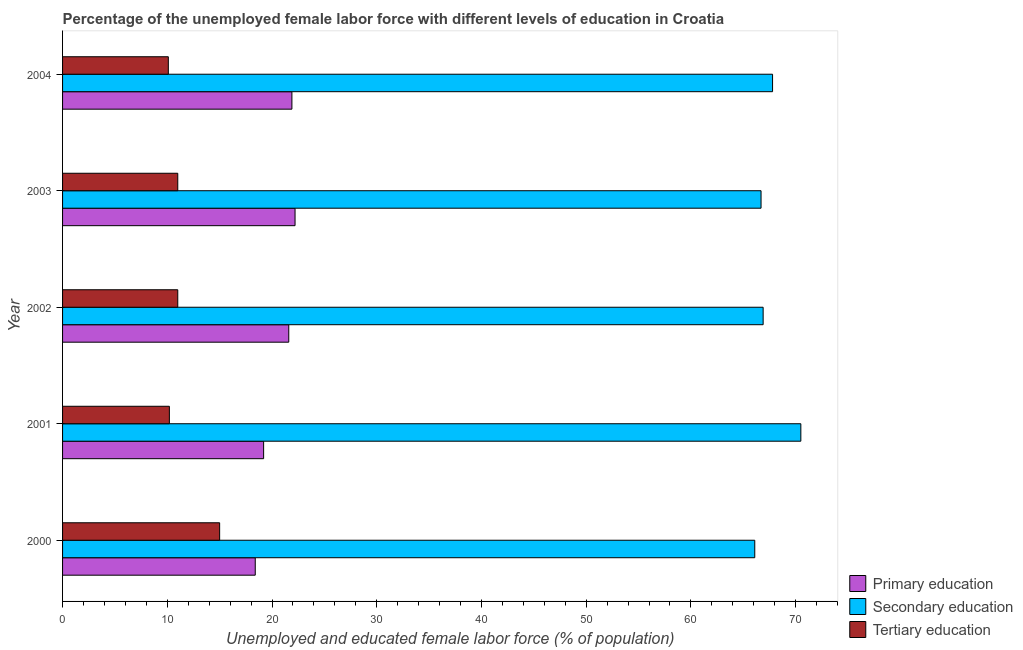Are the number of bars per tick equal to the number of legend labels?
Offer a terse response. Yes. How many bars are there on the 4th tick from the top?
Offer a very short reply. 3. How many bars are there on the 1st tick from the bottom?
Ensure brevity in your answer.  3. What is the percentage of female labor force who received primary education in 2001?
Offer a very short reply. 19.2. Across all years, what is the maximum percentage of female labor force who received secondary education?
Provide a short and direct response. 70.5. Across all years, what is the minimum percentage of female labor force who received secondary education?
Offer a terse response. 66.1. In which year was the percentage of female labor force who received tertiary education minimum?
Offer a terse response. 2004. What is the total percentage of female labor force who received tertiary education in the graph?
Your response must be concise. 57.3. What is the difference between the percentage of female labor force who received primary education in 2003 and that in 2004?
Give a very brief answer. 0.3. What is the difference between the percentage of female labor force who received secondary education in 2003 and the percentage of female labor force who received primary education in 2000?
Make the answer very short. 48.3. What is the average percentage of female labor force who received secondary education per year?
Give a very brief answer. 67.6. In the year 2004, what is the difference between the percentage of female labor force who received tertiary education and percentage of female labor force who received primary education?
Your response must be concise. -11.8. What is the ratio of the percentage of female labor force who received secondary education in 2001 to that in 2003?
Your response must be concise. 1.06. Is the percentage of female labor force who received tertiary education in 2001 less than that in 2002?
Offer a very short reply. Yes. In how many years, is the percentage of female labor force who received secondary education greater than the average percentage of female labor force who received secondary education taken over all years?
Your answer should be compact. 2. Is the sum of the percentage of female labor force who received primary education in 2000 and 2003 greater than the maximum percentage of female labor force who received tertiary education across all years?
Your answer should be compact. Yes. What does the 1st bar from the bottom in 2003 represents?
Offer a very short reply. Primary education. Is it the case that in every year, the sum of the percentage of female labor force who received primary education and percentage of female labor force who received secondary education is greater than the percentage of female labor force who received tertiary education?
Give a very brief answer. Yes. How many years are there in the graph?
Keep it short and to the point. 5. What is the difference between two consecutive major ticks on the X-axis?
Keep it short and to the point. 10. Does the graph contain any zero values?
Offer a very short reply. No. Does the graph contain grids?
Provide a short and direct response. No. Where does the legend appear in the graph?
Ensure brevity in your answer.  Bottom right. How many legend labels are there?
Give a very brief answer. 3. How are the legend labels stacked?
Your response must be concise. Vertical. What is the title of the graph?
Your answer should be compact. Percentage of the unemployed female labor force with different levels of education in Croatia. Does "Poland" appear as one of the legend labels in the graph?
Keep it short and to the point. No. What is the label or title of the X-axis?
Provide a short and direct response. Unemployed and educated female labor force (% of population). What is the Unemployed and educated female labor force (% of population) of Primary education in 2000?
Offer a very short reply. 18.4. What is the Unemployed and educated female labor force (% of population) in Secondary education in 2000?
Ensure brevity in your answer.  66.1. What is the Unemployed and educated female labor force (% of population) of Primary education in 2001?
Your response must be concise. 19.2. What is the Unemployed and educated female labor force (% of population) in Secondary education in 2001?
Make the answer very short. 70.5. What is the Unemployed and educated female labor force (% of population) of Tertiary education in 2001?
Provide a succinct answer. 10.2. What is the Unemployed and educated female labor force (% of population) of Primary education in 2002?
Give a very brief answer. 21.6. What is the Unemployed and educated female labor force (% of population) in Secondary education in 2002?
Offer a very short reply. 66.9. What is the Unemployed and educated female labor force (% of population) of Tertiary education in 2002?
Your answer should be very brief. 11. What is the Unemployed and educated female labor force (% of population) in Primary education in 2003?
Your response must be concise. 22.2. What is the Unemployed and educated female labor force (% of population) of Secondary education in 2003?
Provide a short and direct response. 66.7. What is the Unemployed and educated female labor force (% of population) in Tertiary education in 2003?
Keep it short and to the point. 11. What is the Unemployed and educated female labor force (% of population) of Primary education in 2004?
Give a very brief answer. 21.9. What is the Unemployed and educated female labor force (% of population) in Secondary education in 2004?
Your response must be concise. 67.8. What is the Unemployed and educated female labor force (% of population) in Tertiary education in 2004?
Provide a succinct answer. 10.1. Across all years, what is the maximum Unemployed and educated female labor force (% of population) in Primary education?
Your response must be concise. 22.2. Across all years, what is the maximum Unemployed and educated female labor force (% of population) in Secondary education?
Provide a succinct answer. 70.5. Across all years, what is the maximum Unemployed and educated female labor force (% of population) in Tertiary education?
Ensure brevity in your answer.  15. Across all years, what is the minimum Unemployed and educated female labor force (% of population) of Primary education?
Provide a succinct answer. 18.4. Across all years, what is the minimum Unemployed and educated female labor force (% of population) of Secondary education?
Provide a succinct answer. 66.1. Across all years, what is the minimum Unemployed and educated female labor force (% of population) in Tertiary education?
Ensure brevity in your answer.  10.1. What is the total Unemployed and educated female labor force (% of population) of Primary education in the graph?
Offer a very short reply. 103.3. What is the total Unemployed and educated female labor force (% of population) of Secondary education in the graph?
Keep it short and to the point. 338. What is the total Unemployed and educated female labor force (% of population) in Tertiary education in the graph?
Ensure brevity in your answer.  57.3. What is the difference between the Unemployed and educated female labor force (% of population) in Primary education in 2000 and that in 2001?
Your answer should be very brief. -0.8. What is the difference between the Unemployed and educated female labor force (% of population) in Tertiary education in 2000 and that in 2001?
Your answer should be compact. 4.8. What is the difference between the Unemployed and educated female labor force (% of population) in Secondary education in 2000 and that in 2002?
Your answer should be very brief. -0.8. What is the difference between the Unemployed and educated female labor force (% of population) in Tertiary education in 2000 and that in 2002?
Ensure brevity in your answer.  4. What is the difference between the Unemployed and educated female labor force (% of population) in Tertiary education in 2000 and that in 2003?
Provide a short and direct response. 4. What is the difference between the Unemployed and educated female labor force (% of population) in Primary education in 2000 and that in 2004?
Your response must be concise. -3.5. What is the difference between the Unemployed and educated female labor force (% of population) in Secondary education in 2000 and that in 2004?
Ensure brevity in your answer.  -1.7. What is the difference between the Unemployed and educated female labor force (% of population) of Secondary education in 2001 and that in 2002?
Your response must be concise. 3.6. What is the difference between the Unemployed and educated female labor force (% of population) of Tertiary education in 2001 and that in 2002?
Your answer should be compact. -0.8. What is the difference between the Unemployed and educated female labor force (% of population) in Tertiary education in 2001 and that in 2003?
Your answer should be very brief. -0.8. What is the difference between the Unemployed and educated female labor force (% of population) of Primary education in 2001 and that in 2004?
Provide a succinct answer. -2.7. What is the difference between the Unemployed and educated female labor force (% of population) in Tertiary education in 2001 and that in 2004?
Make the answer very short. 0.1. What is the difference between the Unemployed and educated female labor force (% of population) in Primary education in 2002 and that in 2003?
Provide a short and direct response. -0.6. What is the difference between the Unemployed and educated female labor force (% of population) of Tertiary education in 2002 and that in 2003?
Offer a very short reply. 0. What is the difference between the Unemployed and educated female labor force (% of population) of Secondary education in 2002 and that in 2004?
Provide a short and direct response. -0.9. What is the difference between the Unemployed and educated female labor force (% of population) in Primary education in 2003 and that in 2004?
Offer a very short reply. 0.3. What is the difference between the Unemployed and educated female labor force (% of population) in Primary education in 2000 and the Unemployed and educated female labor force (% of population) in Secondary education in 2001?
Provide a succinct answer. -52.1. What is the difference between the Unemployed and educated female labor force (% of population) in Secondary education in 2000 and the Unemployed and educated female labor force (% of population) in Tertiary education in 2001?
Keep it short and to the point. 55.9. What is the difference between the Unemployed and educated female labor force (% of population) in Primary education in 2000 and the Unemployed and educated female labor force (% of population) in Secondary education in 2002?
Your answer should be very brief. -48.5. What is the difference between the Unemployed and educated female labor force (% of population) in Primary education in 2000 and the Unemployed and educated female labor force (% of population) in Tertiary education in 2002?
Offer a very short reply. 7.4. What is the difference between the Unemployed and educated female labor force (% of population) of Secondary education in 2000 and the Unemployed and educated female labor force (% of population) of Tertiary education in 2002?
Give a very brief answer. 55.1. What is the difference between the Unemployed and educated female labor force (% of population) in Primary education in 2000 and the Unemployed and educated female labor force (% of population) in Secondary education in 2003?
Keep it short and to the point. -48.3. What is the difference between the Unemployed and educated female labor force (% of population) of Secondary education in 2000 and the Unemployed and educated female labor force (% of population) of Tertiary education in 2003?
Offer a very short reply. 55.1. What is the difference between the Unemployed and educated female labor force (% of population) in Primary education in 2000 and the Unemployed and educated female labor force (% of population) in Secondary education in 2004?
Your answer should be compact. -49.4. What is the difference between the Unemployed and educated female labor force (% of population) of Primary education in 2000 and the Unemployed and educated female labor force (% of population) of Tertiary education in 2004?
Your response must be concise. 8.3. What is the difference between the Unemployed and educated female labor force (% of population) of Secondary education in 2000 and the Unemployed and educated female labor force (% of population) of Tertiary education in 2004?
Give a very brief answer. 56. What is the difference between the Unemployed and educated female labor force (% of population) in Primary education in 2001 and the Unemployed and educated female labor force (% of population) in Secondary education in 2002?
Offer a very short reply. -47.7. What is the difference between the Unemployed and educated female labor force (% of population) in Secondary education in 2001 and the Unemployed and educated female labor force (% of population) in Tertiary education in 2002?
Give a very brief answer. 59.5. What is the difference between the Unemployed and educated female labor force (% of population) in Primary education in 2001 and the Unemployed and educated female labor force (% of population) in Secondary education in 2003?
Your answer should be very brief. -47.5. What is the difference between the Unemployed and educated female labor force (% of population) in Primary education in 2001 and the Unemployed and educated female labor force (% of population) in Tertiary education in 2003?
Ensure brevity in your answer.  8.2. What is the difference between the Unemployed and educated female labor force (% of population) of Secondary education in 2001 and the Unemployed and educated female labor force (% of population) of Tertiary education in 2003?
Ensure brevity in your answer.  59.5. What is the difference between the Unemployed and educated female labor force (% of population) of Primary education in 2001 and the Unemployed and educated female labor force (% of population) of Secondary education in 2004?
Offer a very short reply. -48.6. What is the difference between the Unemployed and educated female labor force (% of population) of Primary education in 2001 and the Unemployed and educated female labor force (% of population) of Tertiary education in 2004?
Your response must be concise. 9.1. What is the difference between the Unemployed and educated female labor force (% of population) of Secondary education in 2001 and the Unemployed and educated female labor force (% of population) of Tertiary education in 2004?
Ensure brevity in your answer.  60.4. What is the difference between the Unemployed and educated female labor force (% of population) of Primary education in 2002 and the Unemployed and educated female labor force (% of population) of Secondary education in 2003?
Give a very brief answer. -45.1. What is the difference between the Unemployed and educated female labor force (% of population) in Primary education in 2002 and the Unemployed and educated female labor force (% of population) in Tertiary education in 2003?
Your answer should be very brief. 10.6. What is the difference between the Unemployed and educated female labor force (% of population) of Secondary education in 2002 and the Unemployed and educated female labor force (% of population) of Tertiary education in 2003?
Ensure brevity in your answer.  55.9. What is the difference between the Unemployed and educated female labor force (% of population) in Primary education in 2002 and the Unemployed and educated female labor force (% of population) in Secondary education in 2004?
Give a very brief answer. -46.2. What is the difference between the Unemployed and educated female labor force (% of population) of Secondary education in 2002 and the Unemployed and educated female labor force (% of population) of Tertiary education in 2004?
Provide a short and direct response. 56.8. What is the difference between the Unemployed and educated female labor force (% of population) of Primary education in 2003 and the Unemployed and educated female labor force (% of population) of Secondary education in 2004?
Give a very brief answer. -45.6. What is the difference between the Unemployed and educated female labor force (% of population) of Secondary education in 2003 and the Unemployed and educated female labor force (% of population) of Tertiary education in 2004?
Your response must be concise. 56.6. What is the average Unemployed and educated female labor force (% of population) in Primary education per year?
Keep it short and to the point. 20.66. What is the average Unemployed and educated female labor force (% of population) of Secondary education per year?
Offer a terse response. 67.6. What is the average Unemployed and educated female labor force (% of population) in Tertiary education per year?
Offer a terse response. 11.46. In the year 2000, what is the difference between the Unemployed and educated female labor force (% of population) in Primary education and Unemployed and educated female labor force (% of population) in Secondary education?
Give a very brief answer. -47.7. In the year 2000, what is the difference between the Unemployed and educated female labor force (% of population) in Secondary education and Unemployed and educated female labor force (% of population) in Tertiary education?
Provide a short and direct response. 51.1. In the year 2001, what is the difference between the Unemployed and educated female labor force (% of population) of Primary education and Unemployed and educated female labor force (% of population) of Secondary education?
Ensure brevity in your answer.  -51.3. In the year 2001, what is the difference between the Unemployed and educated female labor force (% of population) of Secondary education and Unemployed and educated female labor force (% of population) of Tertiary education?
Your response must be concise. 60.3. In the year 2002, what is the difference between the Unemployed and educated female labor force (% of population) of Primary education and Unemployed and educated female labor force (% of population) of Secondary education?
Make the answer very short. -45.3. In the year 2002, what is the difference between the Unemployed and educated female labor force (% of population) in Secondary education and Unemployed and educated female labor force (% of population) in Tertiary education?
Make the answer very short. 55.9. In the year 2003, what is the difference between the Unemployed and educated female labor force (% of population) of Primary education and Unemployed and educated female labor force (% of population) of Secondary education?
Your answer should be very brief. -44.5. In the year 2003, what is the difference between the Unemployed and educated female labor force (% of population) of Primary education and Unemployed and educated female labor force (% of population) of Tertiary education?
Give a very brief answer. 11.2. In the year 2003, what is the difference between the Unemployed and educated female labor force (% of population) in Secondary education and Unemployed and educated female labor force (% of population) in Tertiary education?
Ensure brevity in your answer.  55.7. In the year 2004, what is the difference between the Unemployed and educated female labor force (% of population) in Primary education and Unemployed and educated female labor force (% of population) in Secondary education?
Provide a succinct answer. -45.9. In the year 2004, what is the difference between the Unemployed and educated female labor force (% of population) of Secondary education and Unemployed and educated female labor force (% of population) of Tertiary education?
Give a very brief answer. 57.7. What is the ratio of the Unemployed and educated female labor force (% of population) in Secondary education in 2000 to that in 2001?
Your answer should be compact. 0.94. What is the ratio of the Unemployed and educated female labor force (% of population) of Tertiary education in 2000 to that in 2001?
Your answer should be very brief. 1.47. What is the ratio of the Unemployed and educated female labor force (% of population) in Primary education in 2000 to that in 2002?
Provide a short and direct response. 0.85. What is the ratio of the Unemployed and educated female labor force (% of population) in Tertiary education in 2000 to that in 2002?
Make the answer very short. 1.36. What is the ratio of the Unemployed and educated female labor force (% of population) of Primary education in 2000 to that in 2003?
Make the answer very short. 0.83. What is the ratio of the Unemployed and educated female labor force (% of population) in Secondary education in 2000 to that in 2003?
Provide a succinct answer. 0.99. What is the ratio of the Unemployed and educated female labor force (% of population) in Tertiary education in 2000 to that in 2003?
Your answer should be very brief. 1.36. What is the ratio of the Unemployed and educated female labor force (% of population) of Primary education in 2000 to that in 2004?
Keep it short and to the point. 0.84. What is the ratio of the Unemployed and educated female labor force (% of population) of Secondary education in 2000 to that in 2004?
Ensure brevity in your answer.  0.97. What is the ratio of the Unemployed and educated female labor force (% of population) in Tertiary education in 2000 to that in 2004?
Give a very brief answer. 1.49. What is the ratio of the Unemployed and educated female labor force (% of population) in Secondary education in 2001 to that in 2002?
Your answer should be compact. 1.05. What is the ratio of the Unemployed and educated female labor force (% of population) in Tertiary education in 2001 to that in 2002?
Provide a succinct answer. 0.93. What is the ratio of the Unemployed and educated female labor force (% of population) in Primary education in 2001 to that in 2003?
Give a very brief answer. 0.86. What is the ratio of the Unemployed and educated female labor force (% of population) of Secondary education in 2001 to that in 2003?
Provide a succinct answer. 1.06. What is the ratio of the Unemployed and educated female labor force (% of population) of Tertiary education in 2001 to that in 2003?
Your answer should be compact. 0.93. What is the ratio of the Unemployed and educated female labor force (% of population) in Primary education in 2001 to that in 2004?
Your answer should be very brief. 0.88. What is the ratio of the Unemployed and educated female labor force (% of population) in Secondary education in 2001 to that in 2004?
Keep it short and to the point. 1.04. What is the ratio of the Unemployed and educated female labor force (% of population) in Tertiary education in 2001 to that in 2004?
Offer a very short reply. 1.01. What is the ratio of the Unemployed and educated female labor force (% of population) of Primary education in 2002 to that in 2003?
Keep it short and to the point. 0.97. What is the ratio of the Unemployed and educated female labor force (% of population) of Primary education in 2002 to that in 2004?
Keep it short and to the point. 0.99. What is the ratio of the Unemployed and educated female labor force (% of population) in Secondary education in 2002 to that in 2004?
Keep it short and to the point. 0.99. What is the ratio of the Unemployed and educated female labor force (% of population) of Tertiary education in 2002 to that in 2004?
Keep it short and to the point. 1.09. What is the ratio of the Unemployed and educated female labor force (% of population) in Primary education in 2003 to that in 2004?
Keep it short and to the point. 1.01. What is the ratio of the Unemployed and educated female labor force (% of population) in Secondary education in 2003 to that in 2004?
Your response must be concise. 0.98. What is the ratio of the Unemployed and educated female labor force (% of population) of Tertiary education in 2003 to that in 2004?
Your answer should be compact. 1.09. What is the difference between the highest and the second highest Unemployed and educated female labor force (% of population) of Secondary education?
Offer a terse response. 2.7. What is the difference between the highest and the lowest Unemployed and educated female labor force (% of population) of Secondary education?
Provide a short and direct response. 4.4. 